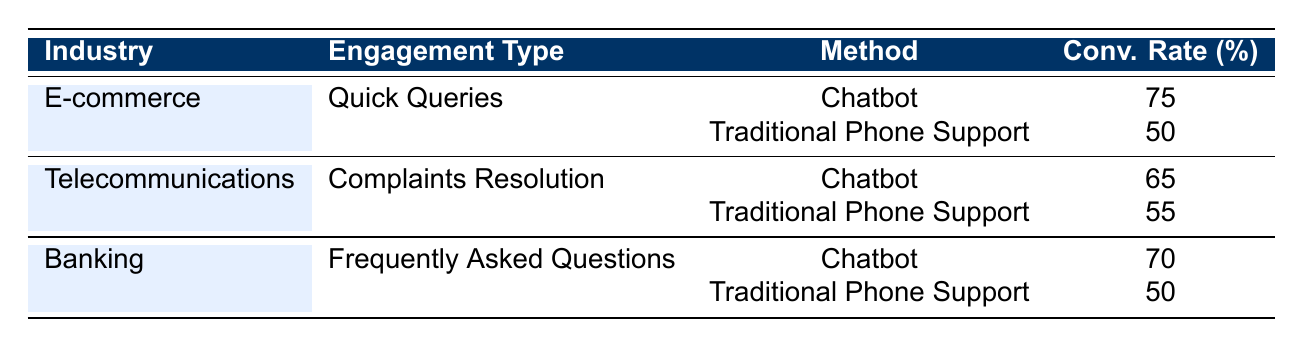What is the conversion rate for chatbots in the e-commerce industry for quick queries? The table lists a conversion rate of 75% for chatbots under the e-commerce category and the engagement type of quick queries.
Answer: 75% Which method has a higher conversion rate for complaints resolution in telecommunications? By comparing the conversion rates, the chatbot has a conversion rate of 65%, while traditional phone support has a conversion rate of 55%. Therefore, chatbot is higher.
Answer: Chatbot What is the difference in conversion rates between chatbots and traditional phone support for the banking industry? The chatbot has a conversion rate of 70% and traditional phone support has 50%. The difference is calculated as 70 - 50 = 20.
Answer: 20% Is the conversion rate for traditional phone support in the e-commerce industry higher than that in the banking industry? The e-commerce conversion rate for traditional phone support is 50%, and for banking, it is also 50%. Since both are equal, the statement is false.
Answer: No What is the average conversion rate for chatbots across all industries listed? To find the average, sum the conversion rates for chatbots: 75 (e-commerce) + 65 (telecommunications) + 70 (banking) = 210. Divide by the number of data points (3) which gives 210 / 3 = 70.
Answer: 70 